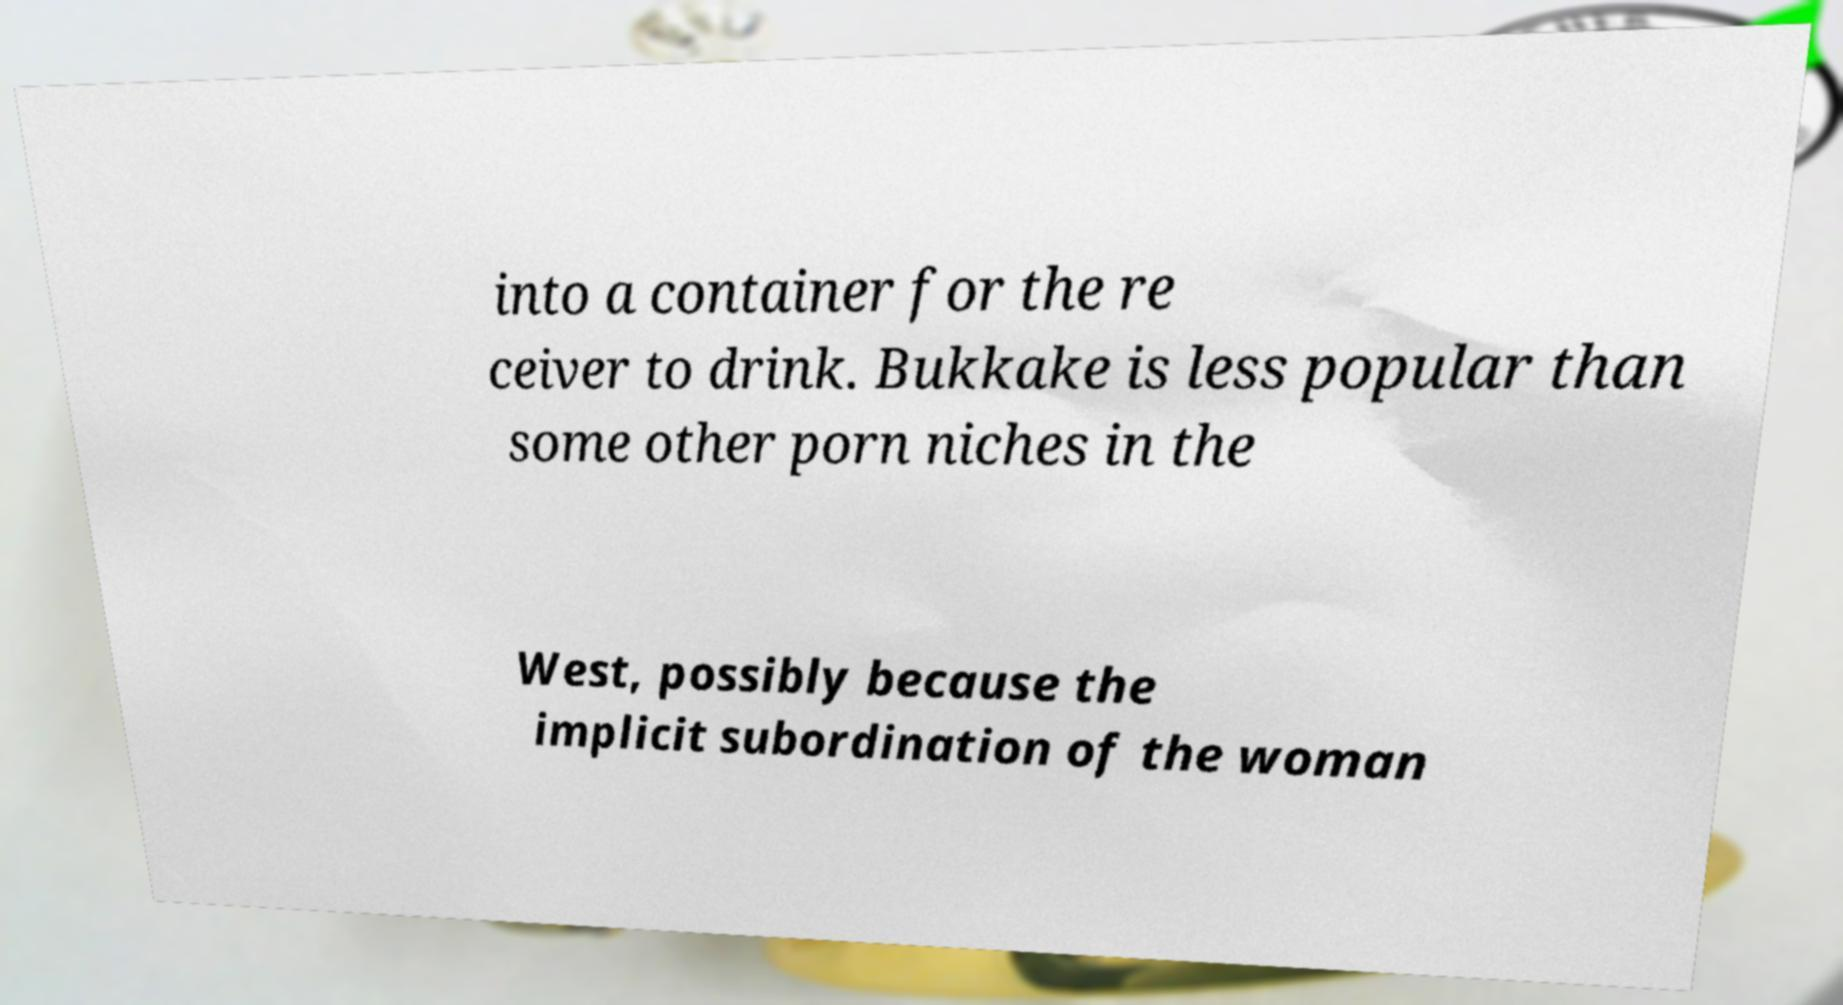For documentation purposes, I need the text within this image transcribed. Could you provide that? into a container for the re ceiver to drink. Bukkake is less popular than some other porn niches in the West, possibly because the implicit subordination of the woman 